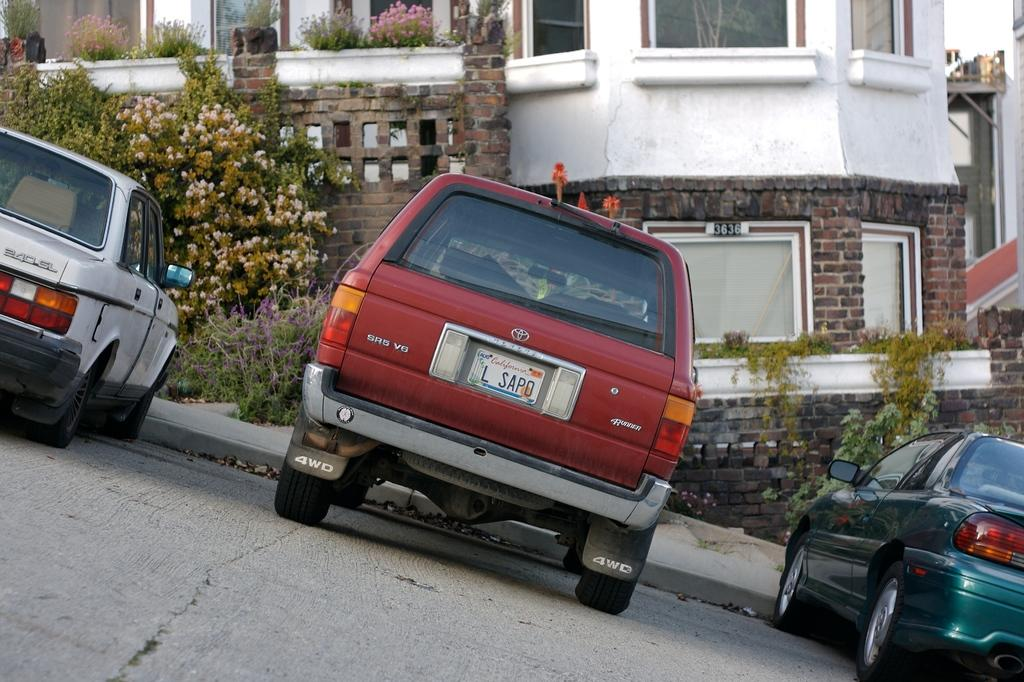What is happening in the image? There are cars on a road in the image. What can be seen in the distance behind the cars? There is a building and plants in the background of the image. What type of cap is the kettle wearing during breakfast in the image? There is no cap, kettle, or breakfast present in the image. 